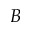Convert formula to latex. <formula><loc_0><loc_0><loc_500><loc_500>B</formula> 